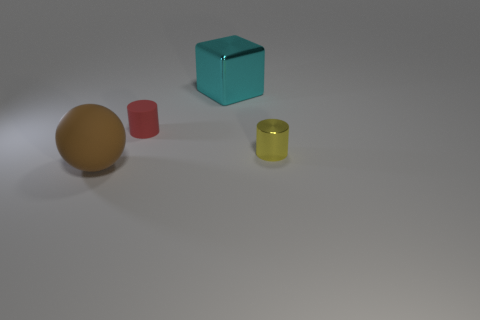Are there more big cyan things behind the big block than cyan objects in front of the yellow metal thing? no 